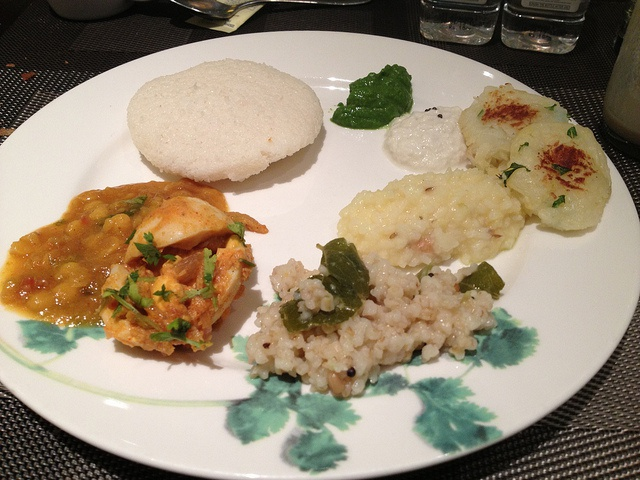Describe the objects in this image and their specific colors. I can see dining table in black and gray tones, cup in black and gray tones, cup in black and gray tones, and spoon in black, maroon, and gray tones in this image. 